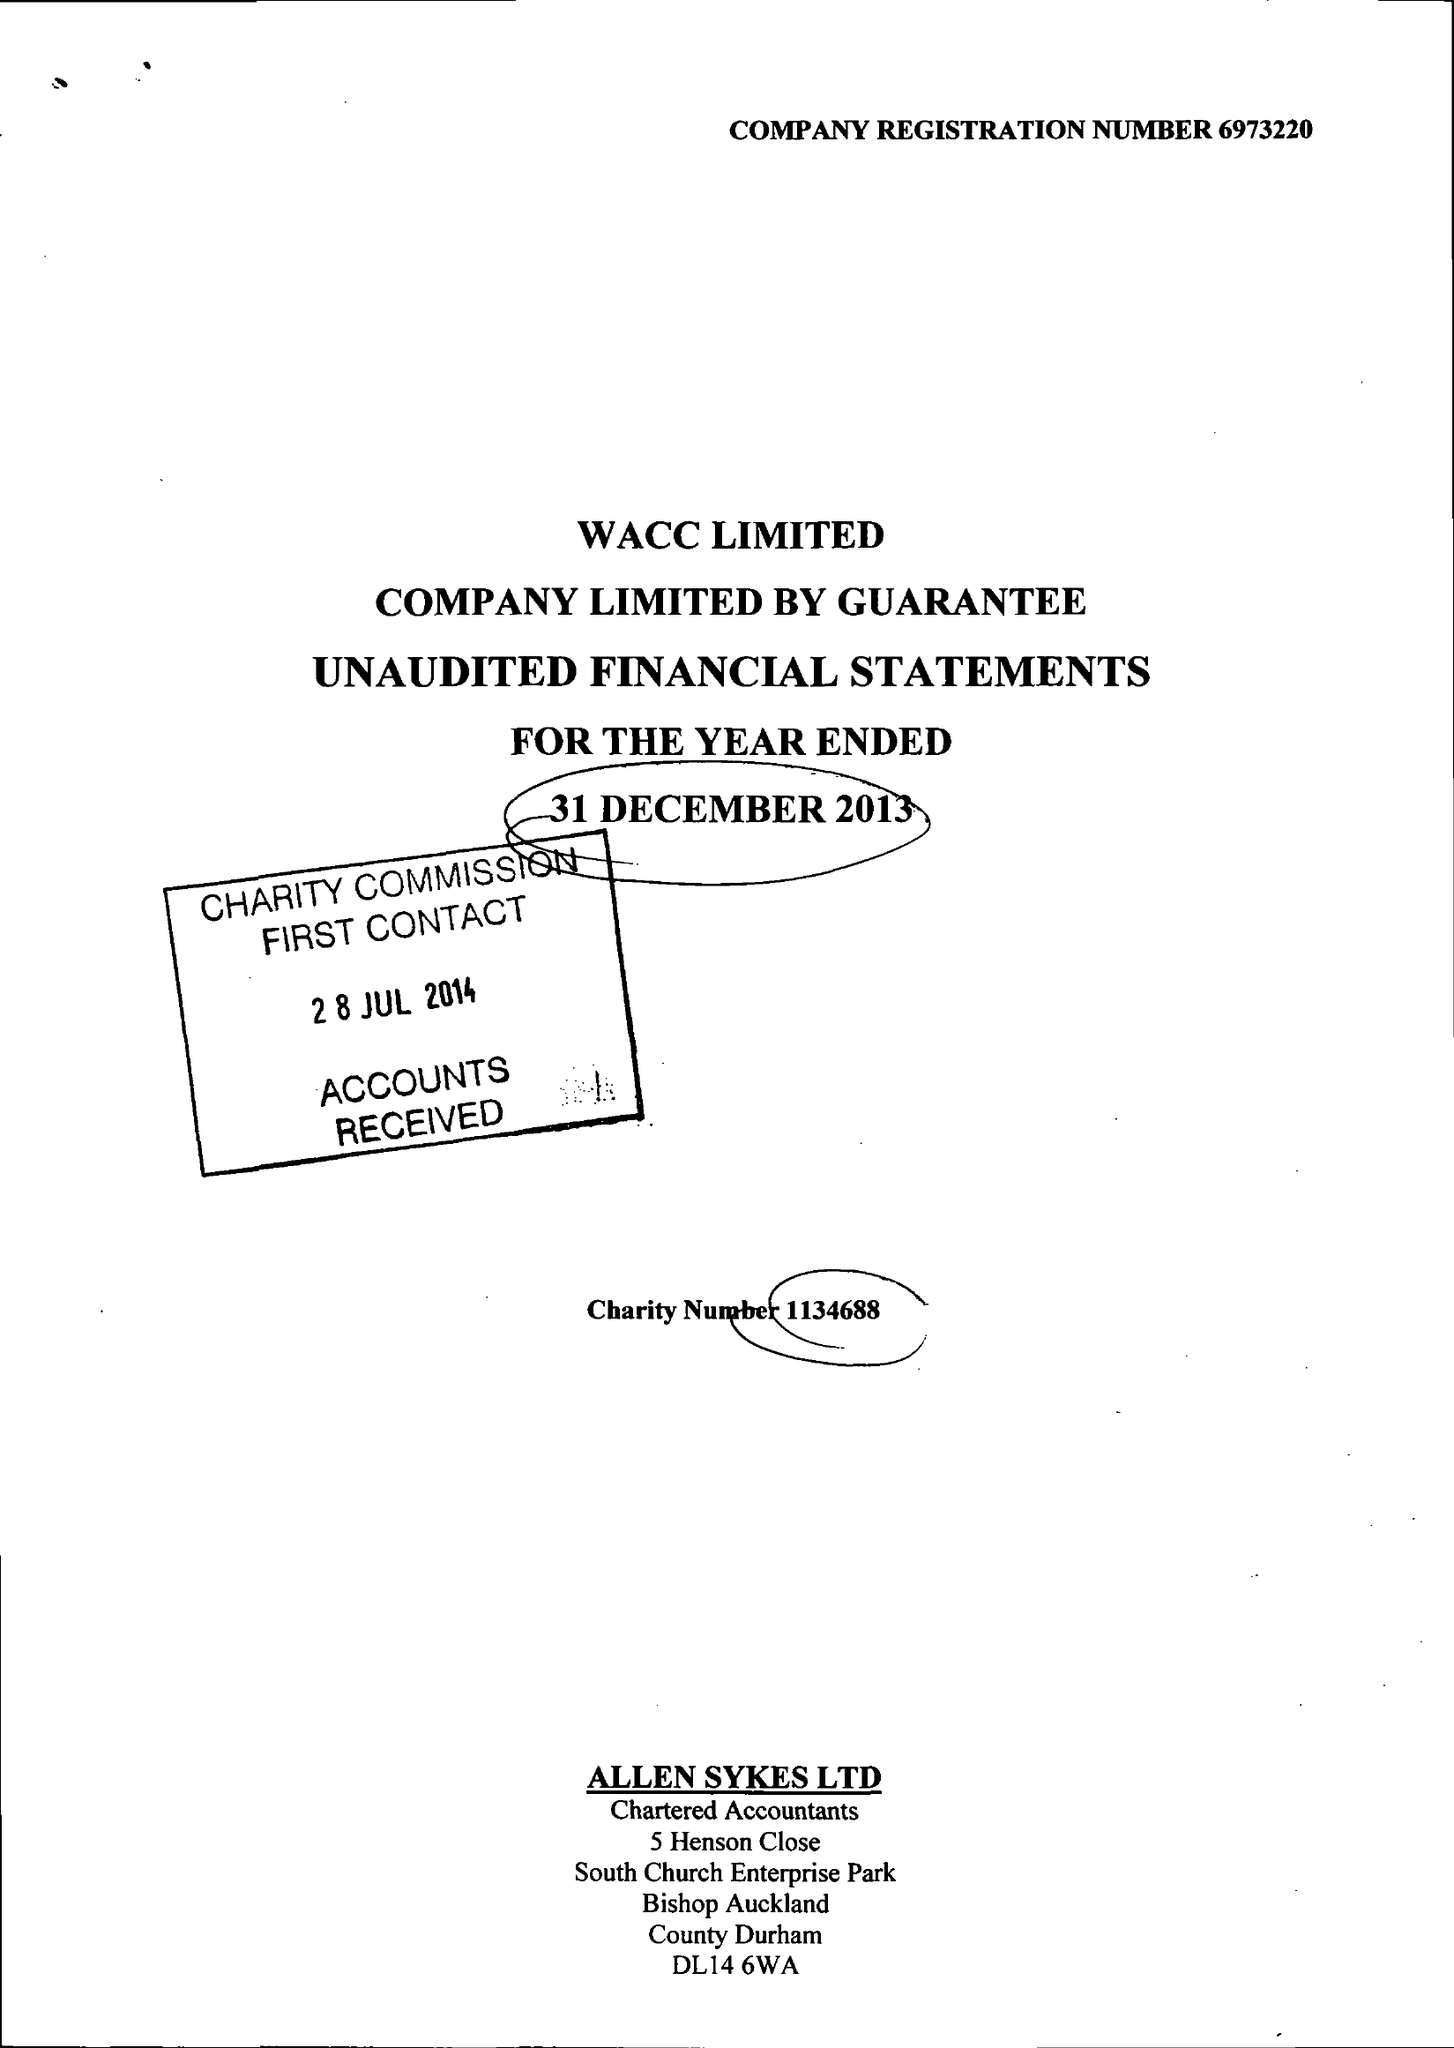What is the value for the address__postcode?
Answer the question using a single word or phrase. DL14 9HJ 